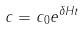Convert formula to latex. <formula><loc_0><loc_0><loc_500><loc_500>c = c _ { 0 } e ^ { \delta H t }</formula> 